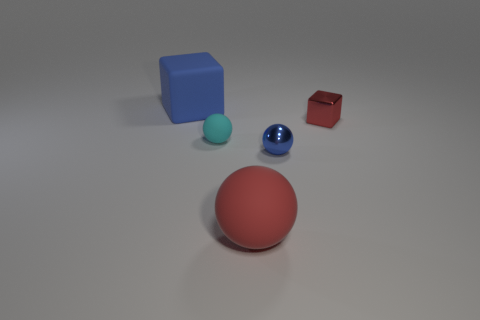There is a matte thing that is both in front of the tiny cube and behind the large matte ball; what is its shape?
Ensure brevity in your answer.  Sphere. The object that is to the right of the metallic thing in front of the cyan rubber sphere is what shape?
Your response must be concise. Cube. Do the tiny blue object and the big red matte object have the same shape?
Give a very brief answer. Yes. There is a thing that is the same color as the big cube; what is its material?
Offer a terse response. Metal. Does the tiny metal block have the same color as the large rubber ball?
Offer a very short reply. Yes. There is a cube that is in front of the matte object behind the red shiny cube; what number of cyan objects are behind it?
Your answer should be compact. 0. What shape is the tiny red object that is the same material as the tiny blue object?
Give a very brief answer. Cube. What is the material of the thing that is right of the blue object to the right of the block behind the small shiny cube?
Your answer should be compact. Metal. What number of things are either tiny things that are in front of the small cyan thing or shiny spheres?
Your response must be concise. 1. What number of other objects are the same shape as the large blue matte thing?
Keep it short and to the point. 1. 